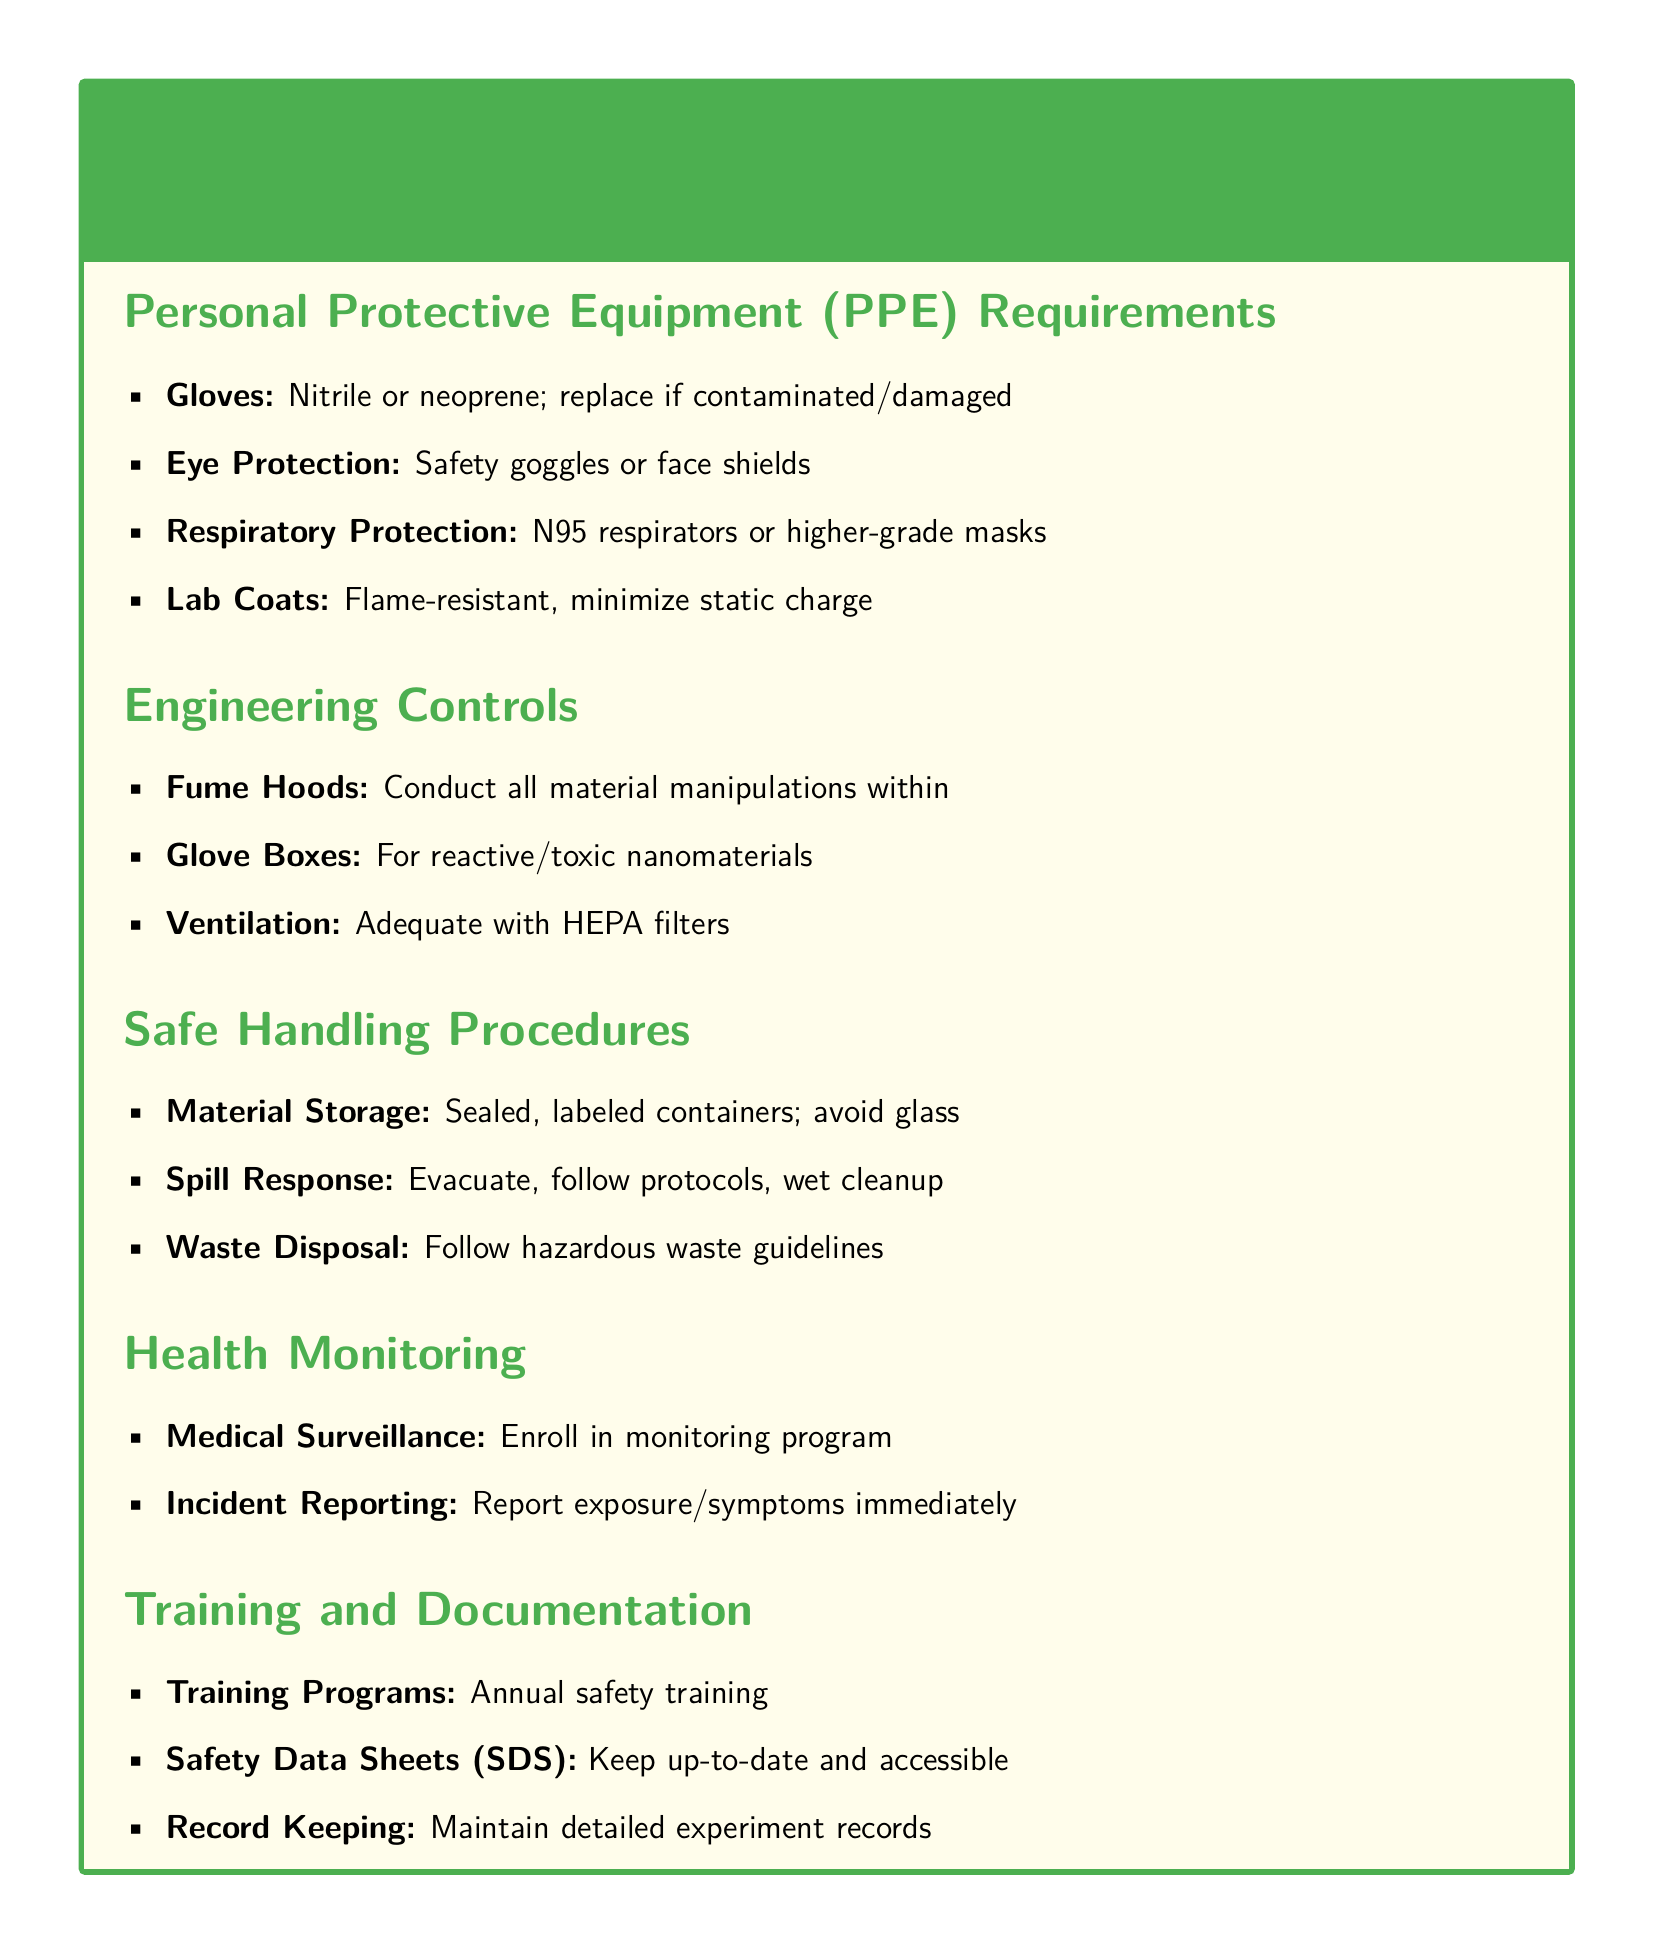What type of gloves are required? The document specifies nitrile or neoprene gloves for protection.
Answer: Nitrile or neoprene What kind of respiratory protection is recommended? The guidelines recommend using N95 respirators or higher-grade masks for respiratory protection.
Answer: N95 respirators or higher-grade masks What should be done in case of a spill? The protocol states to evacuate first, then follow spill response procedures and conduct wet cleanup.
Answer: Evacuate, follow protocols, wet cleanup What should you maintain for health monitoring? The document emphasizes the need to enroll in a medical surveillance program for proper health monitoring.
Answer: Medical surveillance What kind of containers should materials be stored in? Materials should be stored in sealed, labeled containers as advised in the handling procedures.
Answer: Sealed, labeled containers What is one of the engineering controls mentioned? The document lists fume hoods as an important engineering control during material manipulations.
Answer: Fume hoods How often should safety training be conducted? The guidelines specify that safety training programs should be conducted annually.
Answer: Annual What type of lab coat is required? The document specifies that lab coats should be flame-resistant and should minimize static charge.
Answer: Flame-resistant What should you report immediately? Any exposure or symptoms experienced during experiments should be reported immediately as per the guidelines.
Answer: Exposure/symptoms 